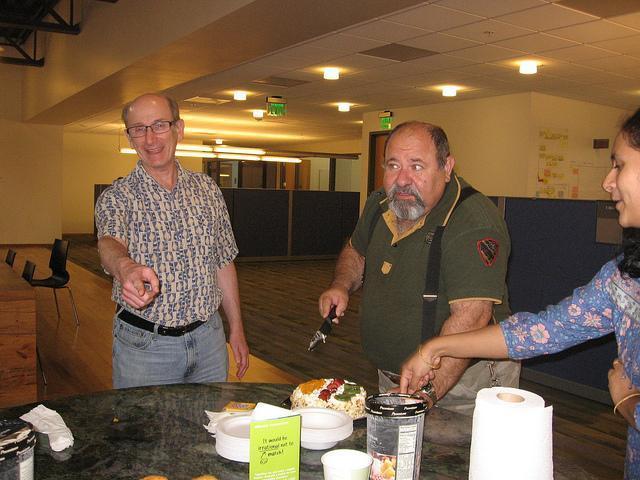How many people are in the pic?
Give a very brief answer. 3. How many people are there?
Give a very brief answer. 3. 